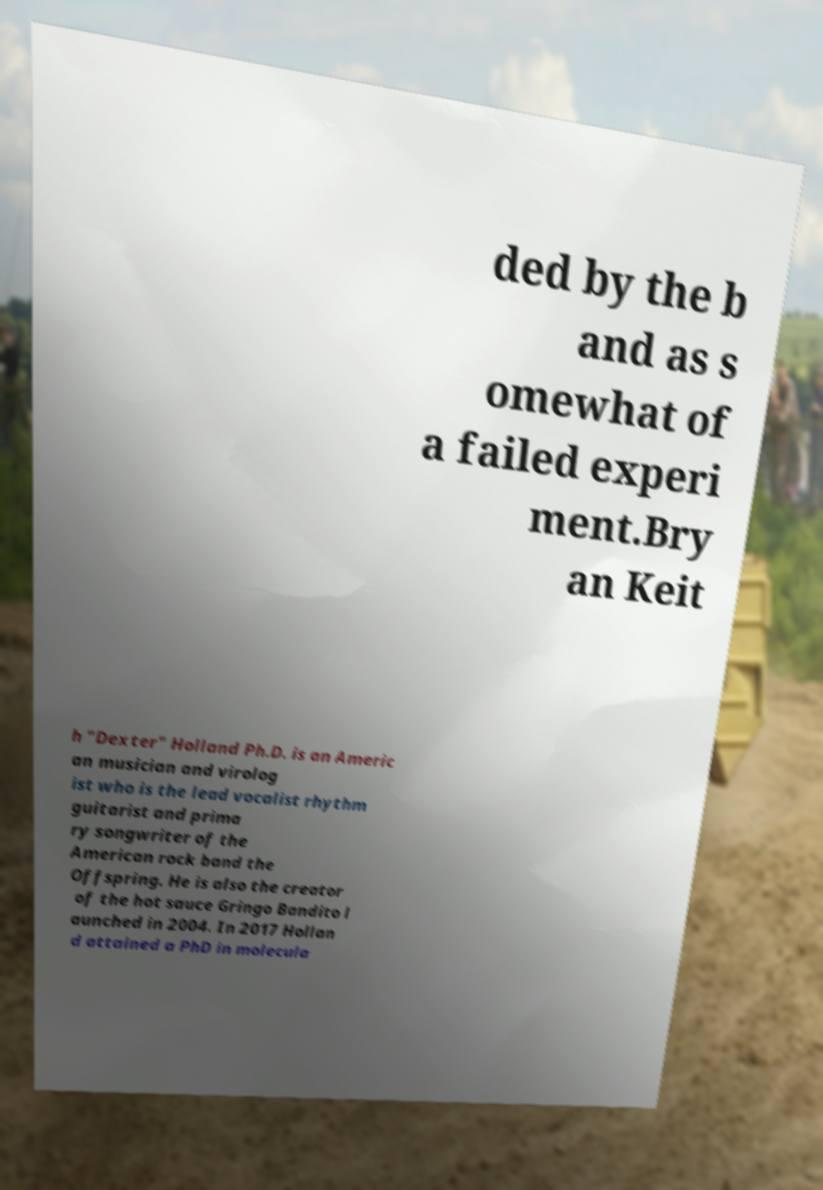What messages or text are displayed in this image? I need them in a readable, typed format. ded by the b and as s omewhat of a failed experi ment.Bry an Keit h "Dexter" Holland Ph.D. is an Americ an musician and virolog ist who is the lead vocalist rhythm guitarist and prima ry songwriter of the American rock band the Offspring. He is also the creator of the hot sauce Gringo Bandito l aunched in 2004. In 2017 Hollan d attained a PhD in molecula 